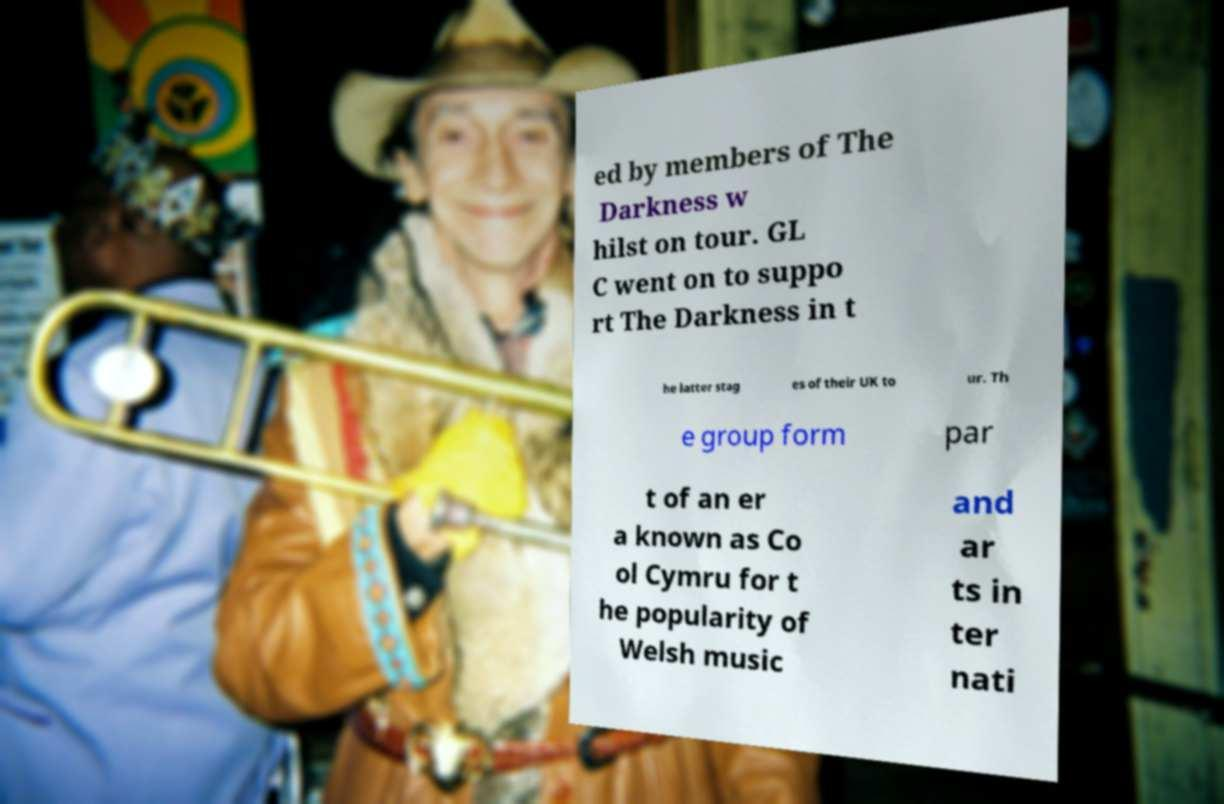Can you accurately transcribe the text from the provided image for me? ed by members of The Darkness w hilst on tour. GL C went on to suppo rt The Darkness in t he latter stag es of their UK to ur. Th e group form par t of an er a known as Co ol Cymru for t he popularity of Welsh music and ar ts in ter nati 